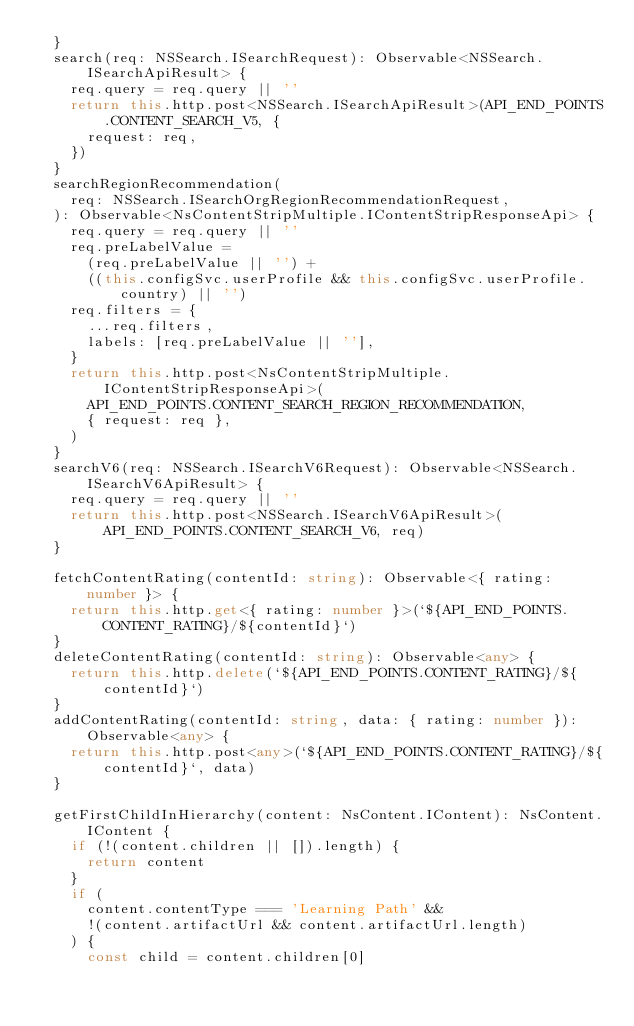<code> <loc_0><loc_0><loc_500><loc_500><_TypeScript_>  }
  search(req: NSSearch.ISearchRequest): Observable<NSSearch.ISearchApiResult> {
    req.query = req.query || ''
    return this.http.post<NSSearch.ISearchApiResult>(API_END_POINTS.CONTENT_SEARCH_V5, {
      request: req,
    })
  }
  searchRegionRecommendation(
    req: NSSearch.ISearchOrgRegionRecommendationRequest,
  ): Observable<NsContentStripMultiple.IContentStripResponseApi> {
    req.query = req.query || ''
    req.preLabelValue =
      (req.preLabelValue || '') +
      ((this.configSvc.userProfile && this.configSvc.userProfile.country) || '')
    req.filters = {
      ...req.filters,
      labels: [req.preLabelValue || ''],
    }
    return this.http.post<NsContentStripMultiple.IContentStripResponseApi>(
      API_END_POINTS.CONTENT_SEARCH_REGION_RECOMMENDATION,
      { request: req },
    )
  }
  searchV6(req: NSSearch.ISearchV6Request): Observable<NSSearch.ISearchV6ApiResult> {
    req.query = req.query || ''
    return this.http.post<NSSearch.ISearchV6ApiResult>(API_END_POINTS.CONTENT_SEARCH_V6, req)
  }

  fetchContentRating(contentId: string): Observable<{ rating: number }> {
    return this.http.get<{ rating: number }>(`${API_END_POINTS.CONTENT_RATING}/${contentId}`)
  }
  deleteContentRating(contentId: string): Observable<any> {
    return this.http.delete(`${API_END_POINTS.CONTENT_RATING}/${contentId}`)
  }
  addContentRating(contentId: string, data: { rating: number }): Observable<any> {
    return this.http.post<any>(`${API_END_POINTS.CONTENT_RATING}/${contentId}`, data)
  }

  getFirstChildInHierarchy(content: NsContent.IContent): NsContent.IContent {
    if (!(content.children || []).length) {
      return content
    }
    if (
      content.contentType === 'Learning Path' &&
      !(content.artifactUrl && content.artifactUrl.length)
    ) {
      const child = content.children[0]</code> 